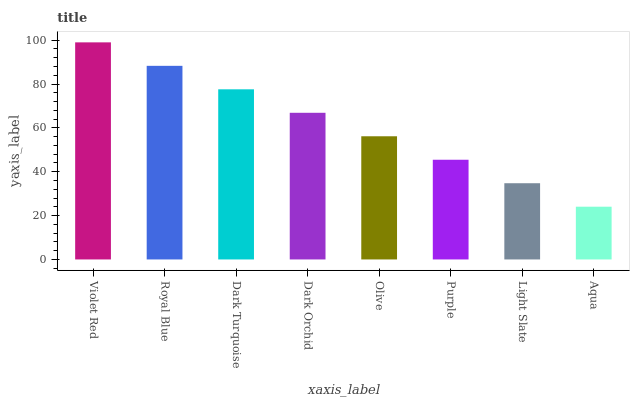Is Aqua the minimum?
Answer yes or no. Yes. Is Violet Red the maximum?
Answer yes or no. Yes. Is Royal Blue the minimum?
Answer yes or no. No. Is Royal Blue the maximum?
Answer yes or no. No. Is Violet Red greater than Royal Blue?
Answer yes or no. Yes. Is Royal Blue less than Violet Red?
Answer yes or no. Yes. Is Royal Blue greater than Violet Red?
Answer yes or no. No. Is Violet Red less than Royal Blue?
Answer yes or no. No. Is Dark Orchid the high median?
Answer yes or no. Yes. Is Olive the low median?
Answer yes or no. Yes. Is Olive the high median?
Answer yes or no. No. Is Light Slate the low median?
Answer yes or no. No. 